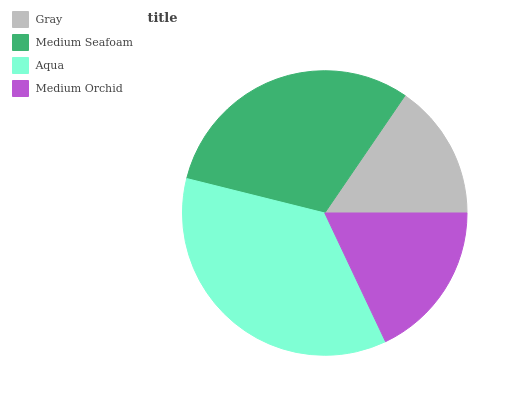Is Gray the minimum?
Answer yes or no. Yes. Is Aqua the maximum?
Answer yes or no. Yes. Is Medium Seafoam the minimum?
Answer yes or no. No. Is Medium Seafoam the maximum?
Answer yes or no. No. Is Medium Seafoam greater than Gray?
Answer yes or no. Yes. Is Gray less than Medium Seafoam?
Answer yes or no. Yes. Is Gray greater than Medium Seafoam?
Answer yes or no. No. Is Medium Seafoam less than Gray?
Answer yes or no. No. Is Medium Seafoam the high median?
Answer yes or no. Yes. Is Medium Orchid the low median?
Answer yes or no. Yes. Is Aqua the high median?
Answer yes or no. No. Is Gray the low median?
Answer yes or no. No. 